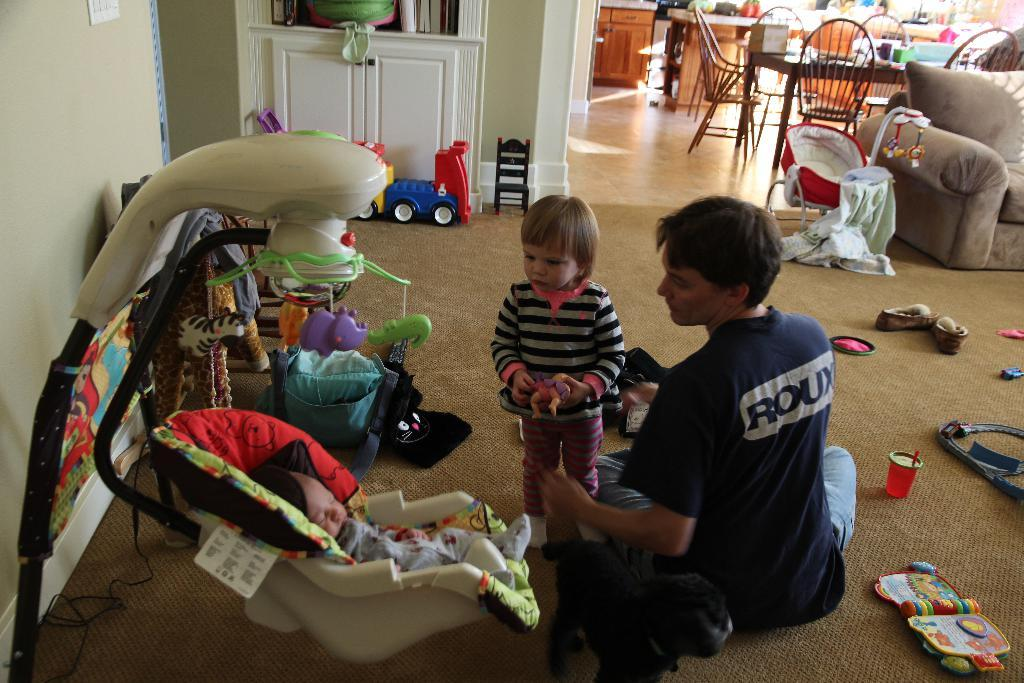What is the main subject of the image? The main subject of the image is a baby in a stroller. What is the kid in the image doing? There is a kid standing in the image. What is the person in the image doing? There is a person sitting in the image. What type of objects are on the floor in the image? There are toys on the carpet in the image. What type of furniture is present in the image? There are chairs, a table, a couch, and cupboards in the image. What type of soft furnishings are present in the image? There are pillows in the image. What fact can be learned about the condition of the baby's teeth from the image? There is no information about the baby's teeth in the image, so it is not possible to determine their condition. 